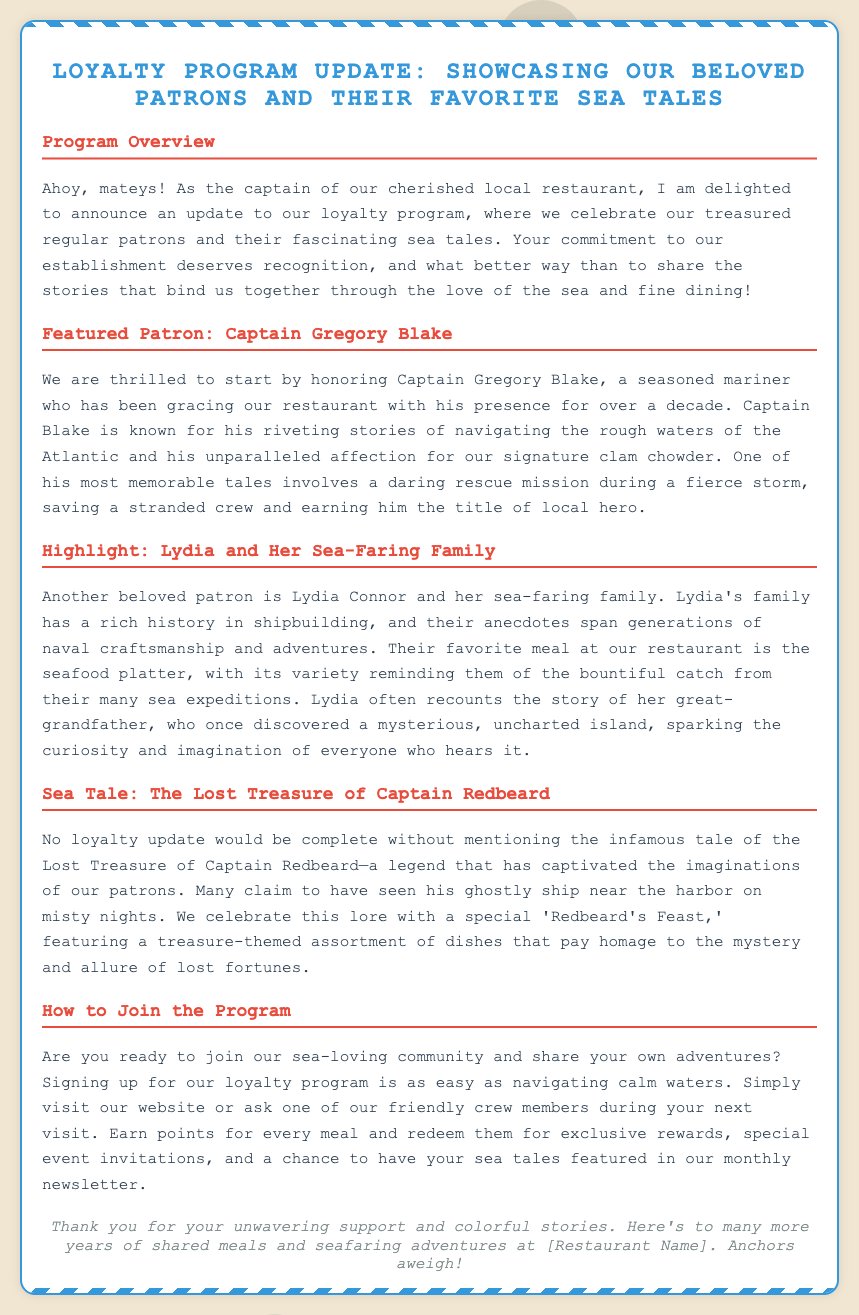what is the title of the update? The title of the update is prominently featured at the top of the document.
Answer: Loyalty Program Update: Showcasing Our Beloved Patrons and Their Favorite Sea Tales who is the first featured patron? The first featured patron mentioned in the update is highlighted in a specific section.
Answer: Captain Gregory Blake what dish does Captain Blake enjoy? The document details Captain Blake's favorite dish in his featured section.
Answer: clam chowder what is the name of Lydia's family? The document names Lydia's family at the beginning of their highlighted section.
Answer: Connor what legendary tale is discussed in the document? The document mentions a specific legendary tale related to lost treasure.
Answer: The Lost Treasure of Captain Redbeard how long has Captain Gregory Blake been visiting the restaurant? The document specifies the duration of Captain Blake's patronage in years.
Answer: over a decade what is the seafood platter known for? The document describes the seafood platter in relation to Lydia's family.
Answer: variety reminding them of the bountiful catch what is the special dish associated with Captain Redbeard? The document mentions a special dish that celebrates the legend of Captain Redbeard.
Answer: Redbeard's Feast how can someone join the loyalty program? The document provides a straightforward way to join the loyalty program.
Answer: visit our website or ask one of our friendly crew members during your next visit 